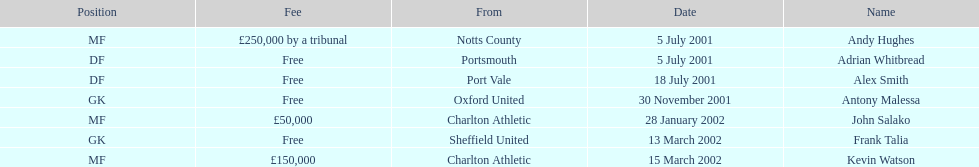Whose name appears last in the chart? Kevin Watson. 